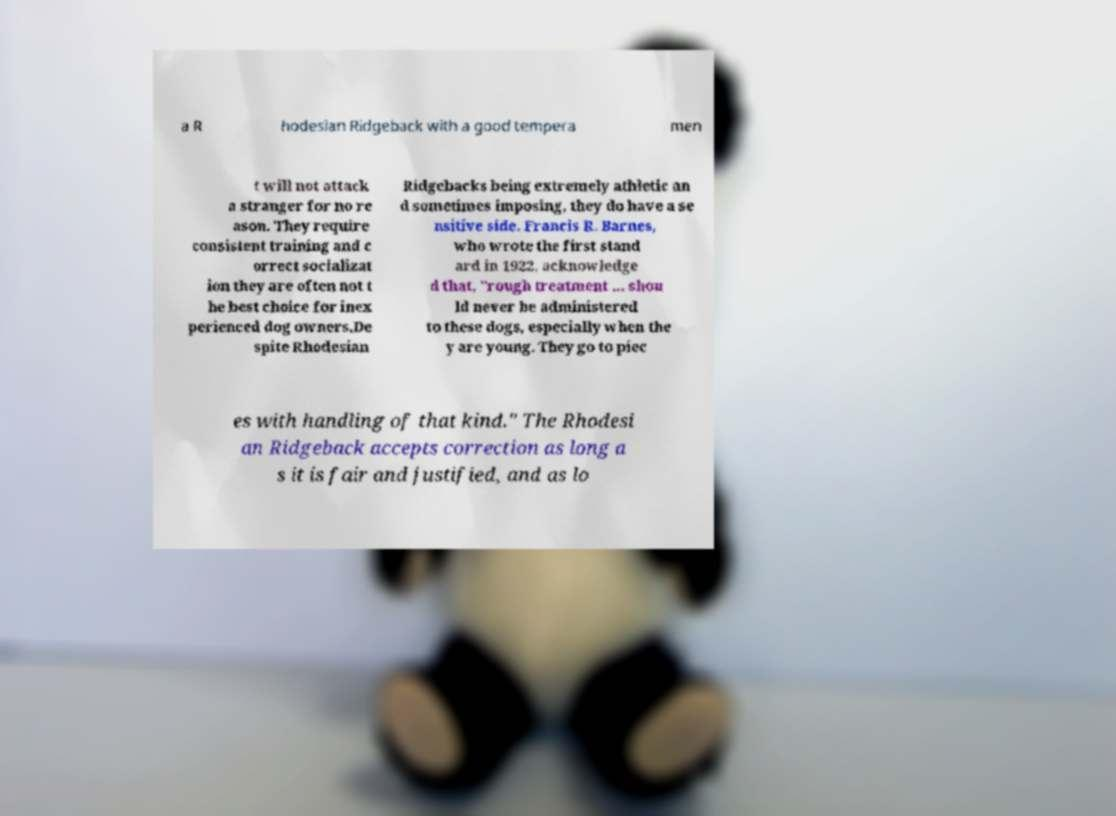Can you accurately transcribe the text from the provided image for me? a R hodesian Ridgeback with a good tempera men t will not attack a stranger for no re ason. They require consistent training and c orrect socializat ion they are often not t he best choice for inex perienced dog owners.De spite Rhodesian Ridgebacks being extremely athletic an d sometimes imposing, they do have a se nsitive side. Francis R. Barnes, who wrote the first stand ard in 1922, acknowledge d that, "rough treatment ... shou ld never be administered to these dogs, especially when the y are young. They go to piec es with handling of that kind." The Rhodesi an Ridgeback accepts correction as long a s it is fair and justified, and as lo 